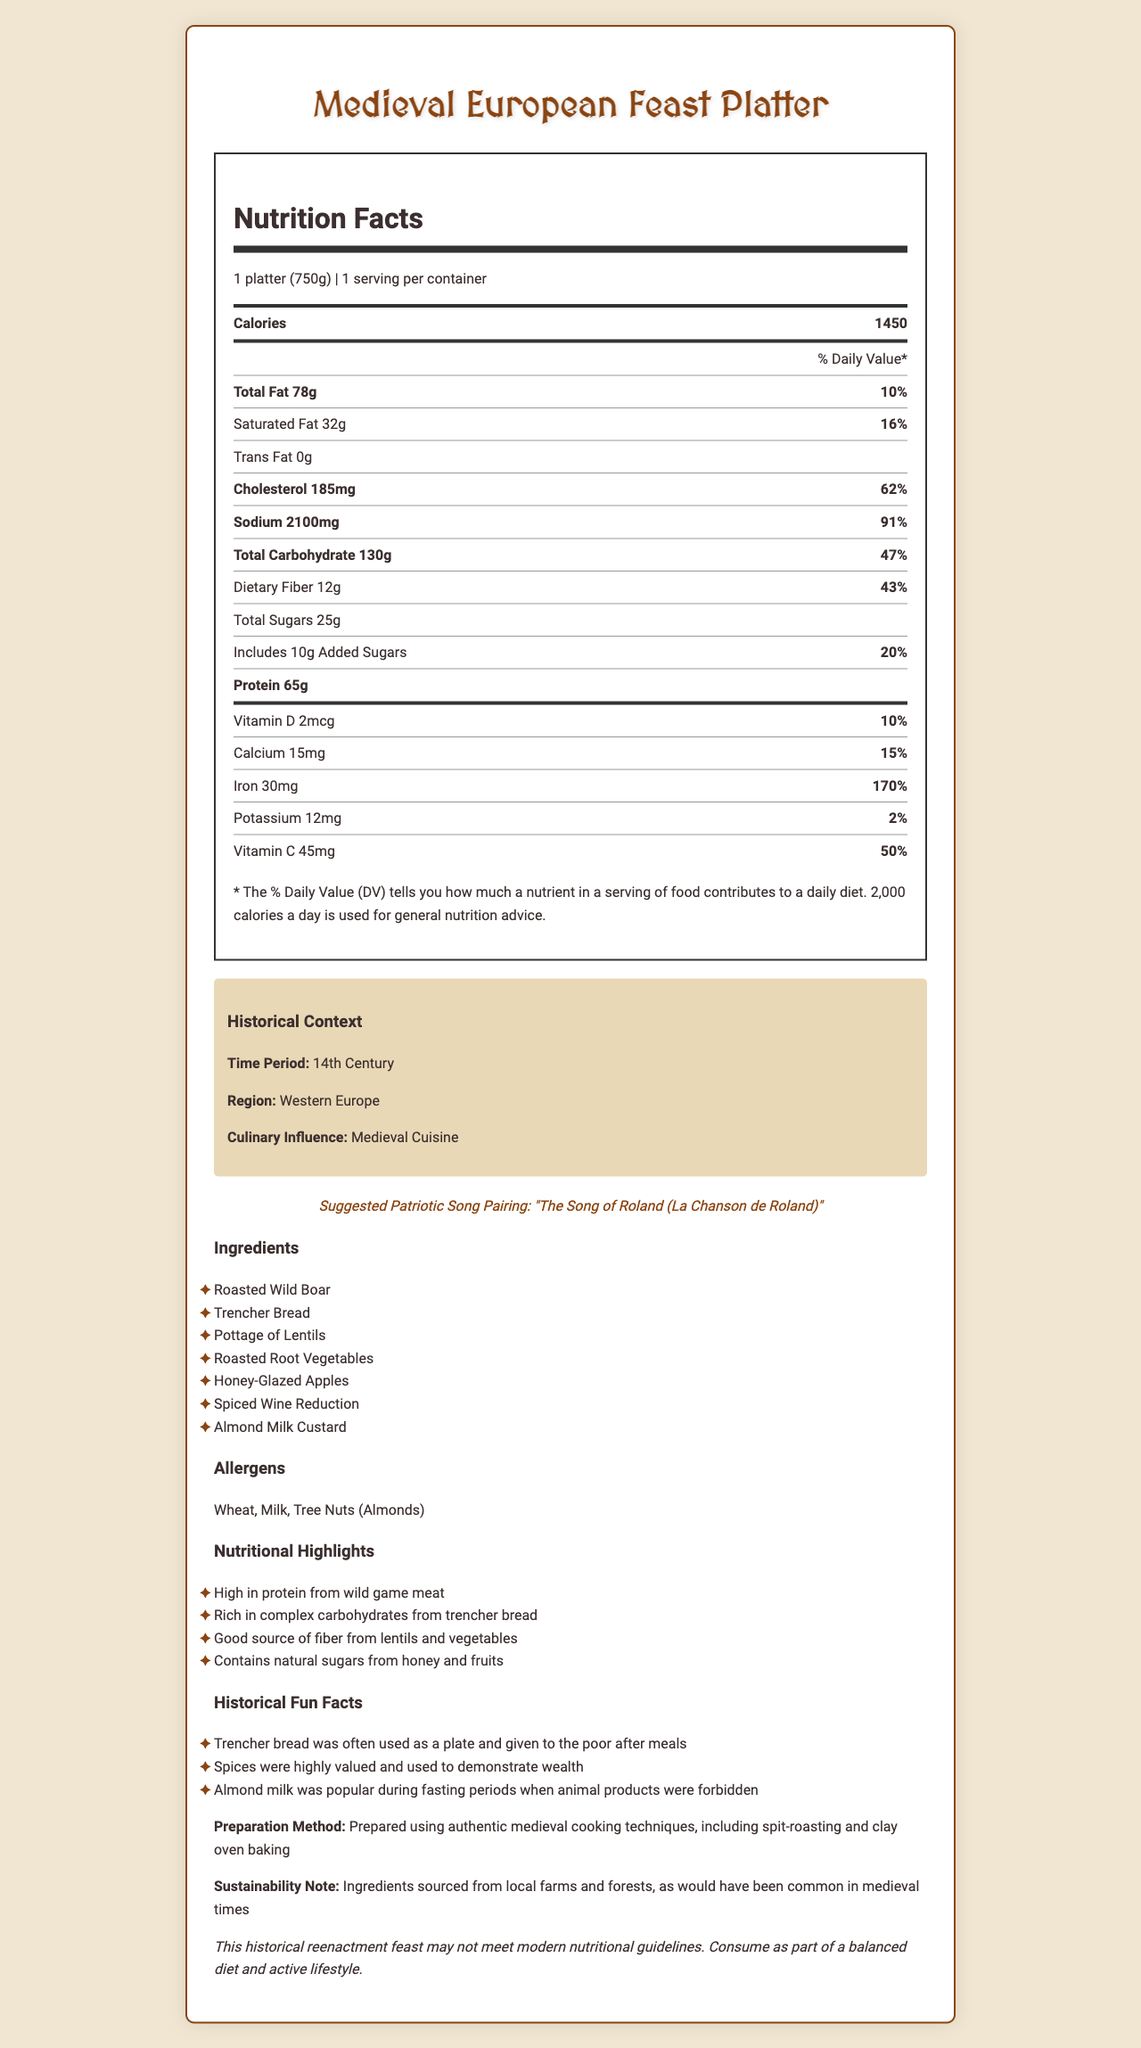what is the serving size for the Medieval European Feast Platter? The document lists the serving size as "1 platter (750g)."
Answer: 1 platter (750g) how many calories are in the Medieval European Feast Platter? The document states that the platter contains 1450 calories.
Answer: 1450 calories what is the suggested patriotic song pairing for the feast? The document mentions "The Song of Roland (La Chanson de Roland)" as the suggested patriotic song pairing.
Answer: The Song of Roland (La Chanson de Roland) list three ingredients in the Medieval European Feast Platter. The document lists multiple ingredients, including "Roasted Wild Boar," "Trencher Bread," and "Pottage of Lentils."
Answer: Roasted Wild Boar, Trencher Bread, Pottage of Lentils what are the listed allergens in the feast? The document lists the allergens as "Wheat, Milk, Tree Nuts (Almonds)."
Answer: Wheat, Milk, Tree Nuts (Almonds) how much protein is in the platter? The document states that the platter contains 65g of protein.
Answer: 65g which nutrient has the highest % Daily Value? A. Vitamins B. Sodium C. Iron The document lists Iron with a 170% Daily Value, which is the highest among the listed nutrients.
Answer: C. Iron what is the sodium content of the platter? A. 1500mg B. 2100mg C. 1750mg The document states that the sodium content is 2100mg.
Answer: B. 2100mg is the platter described as containing any trans fat? The document lists 0 grams of trans fat.
Answer: No does the document mention any methods used to prepare the feast? The document states, "Prepared using authentic medieval cooking techniques, including spit-roasting and clay oven baking."
Answer: Yes summarize the main idea of the document. The document provides comprehensive details on the Medieval European Feast Platter, including its nutritional content and historical significance. It discusses the ingredients and preparation methods and suggests pairing the platter with "The Song of Roland." Additionally, it offers historical insights and facts related to medieval cuisine.
Answer: The document describes the Medieval European Feast Platter, providing nutrition facts, ingredients, historical context, allergens, preparation methods, and a suggested patriotic song pairing. It highlights the platter's high protein and fiber content and includes fun facts about medieval dining habits. what is the exact percentage of the daily value for dietary fiber? The document lists the daily value for dietary fiber as 43%.
Answer: 43% can we determine the exact percentage of daily value for total carbohydrates? The document states that the % Daily Value for total carbohydrates is 47%.
Answer: Yes what kind of cooking techniques were used? The document states that the preparation includes "authentic medieval cooking techniques, including spit-roasting and clay oven baking."
Answer: Spit-roasting and clay oven baking who was the chef that prepared the feast? The document does not provide information about the chef that prepared the feast.
Answer: Cannot be determined 